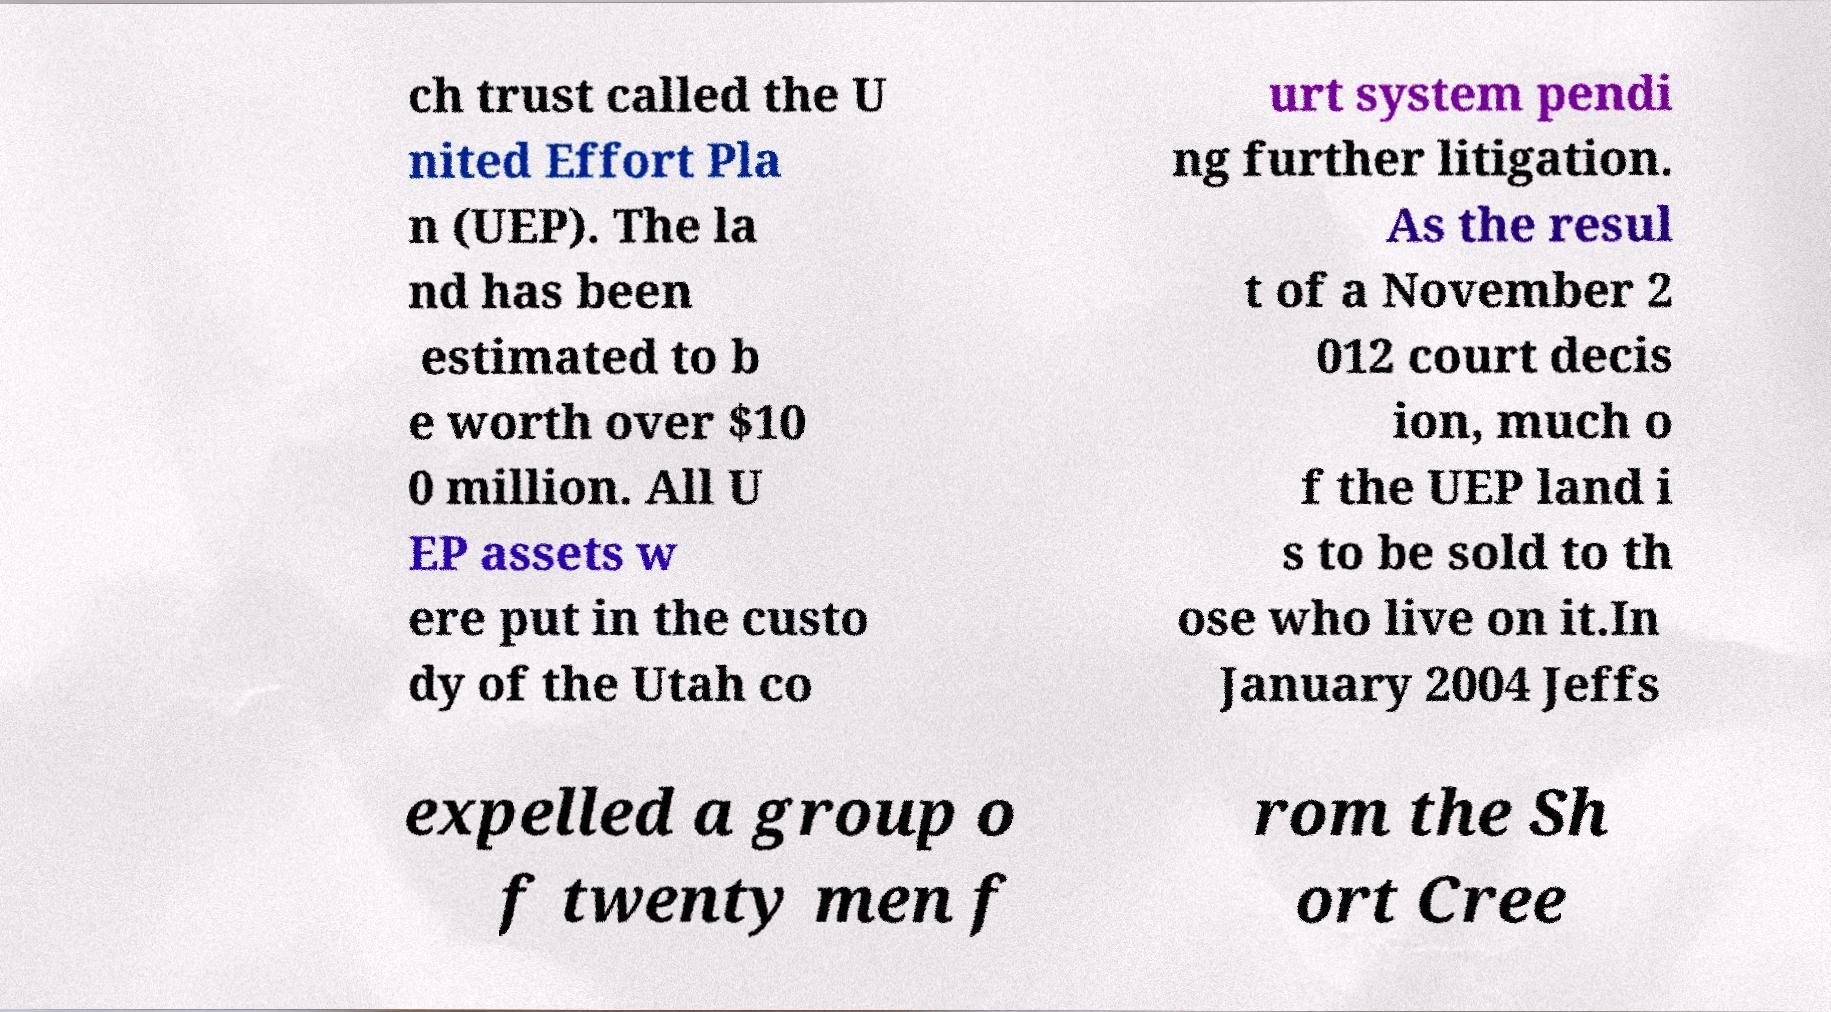Could you extract and type out the text from this image? ch trust called the U nited Effort Pla n (UEP). The la nd has been estimated to b e worth over $10 0 million. All U EP assets w ere put in the custo dy of the Utah co urt system pendi ng further litigation. As the resul t of a November 2 012 court decis ion, much o f the UEP land i s to be sold to th ose who live on it.In January 2004 Jeffs expelled a group o f twenty men f rom the Sh ort Cree 